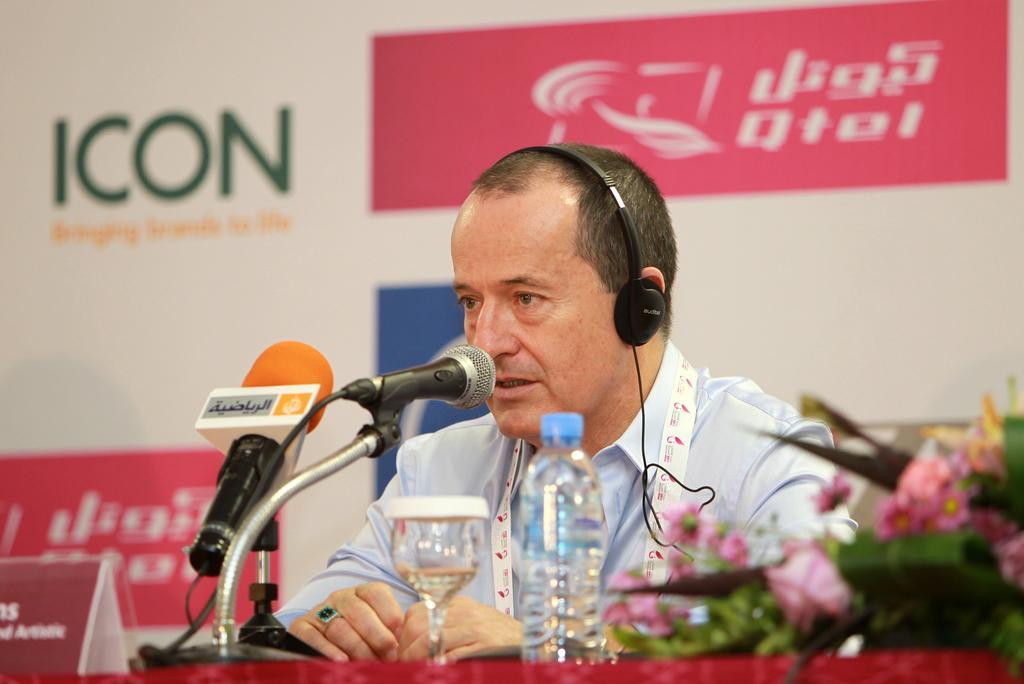In one or two sentences, can you explain what this image depicts? In the foreground of this image, there is a man sitting and there are mics, glass, bottle, table, name board and a bouquet in front of him. In the background, there is a banner wall. 